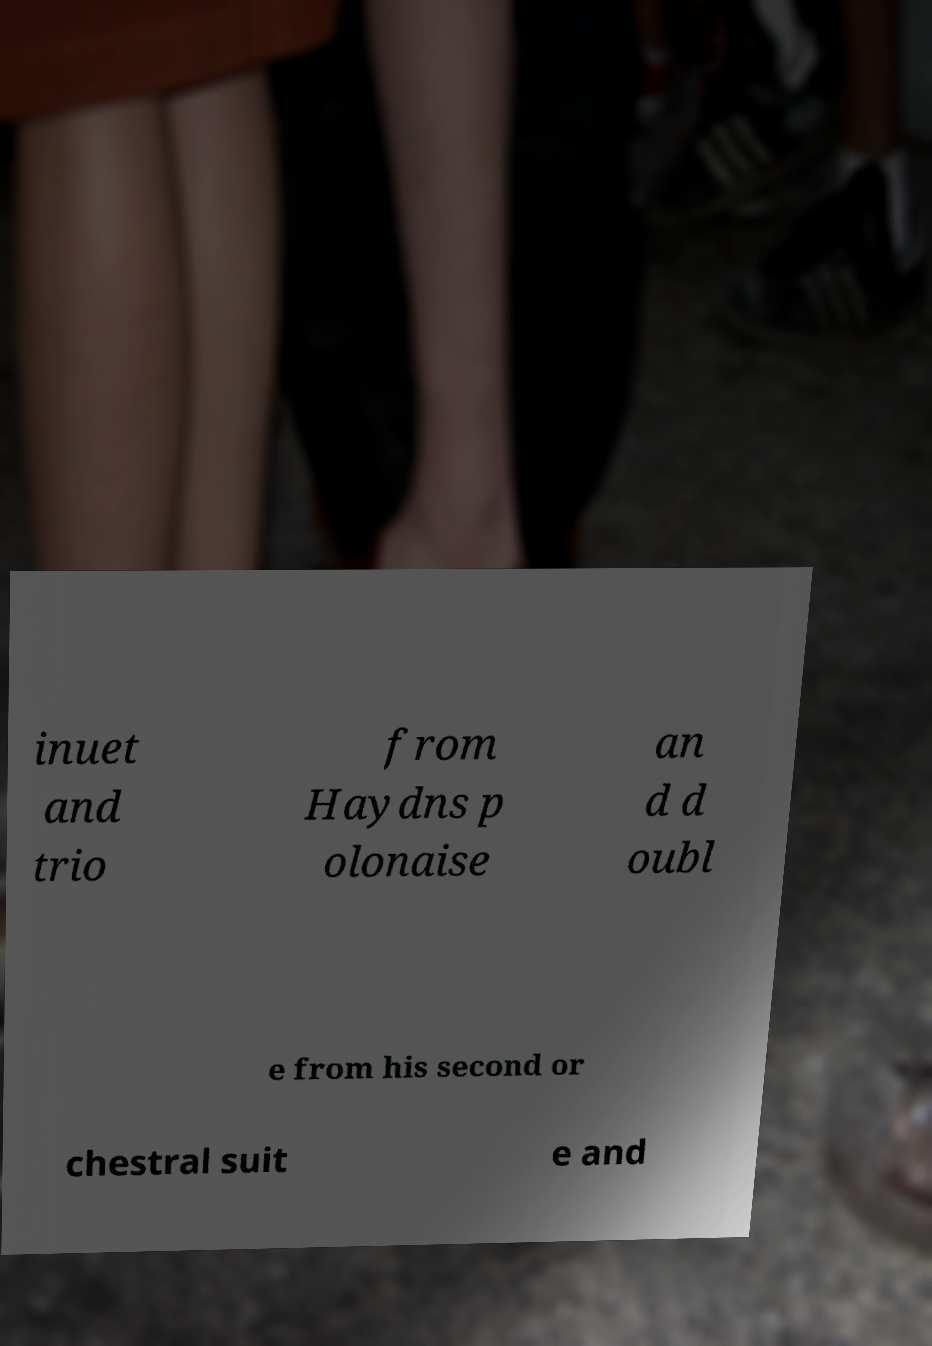What messages or text are displayed in this image? I need them in a readable, typed format. inuet and trio from Haydns p olonaise an d d oubl e from his second or chestral suit e and 